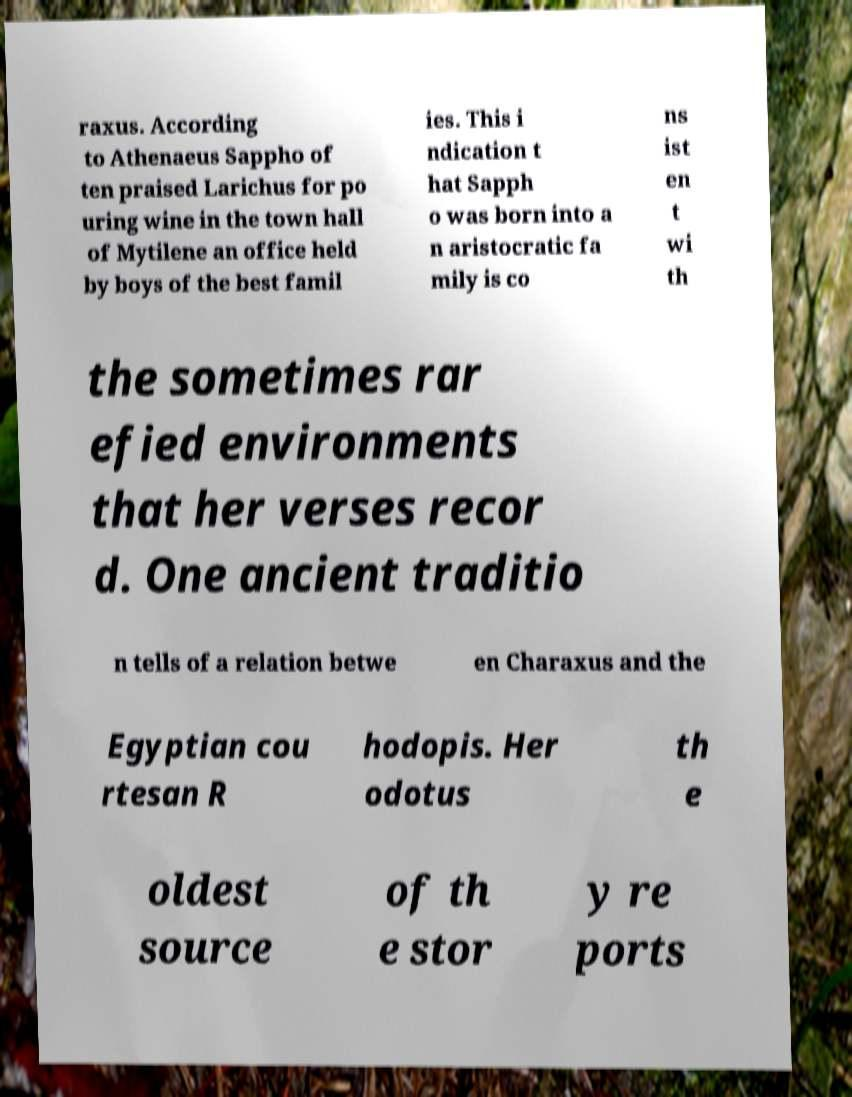Can you accurately transcribe the text from the provided image for me? raxus. According to Athenaeus Sappho of ten praised Larichus for po uring wine in the town hall of Mytilene an office held by boys of the best famil ies. This i ndication t hat Sapph o was born into a n aristocratic fa mily is co ns ist en t wi th the sometimes rar efied environments that her verses recor d. One ancient traditio n tells of a relation betwe en Charaxus and the Egyptian cou rtesan R hodopis. Her odotus th e oldest source of th e stor y re ports 